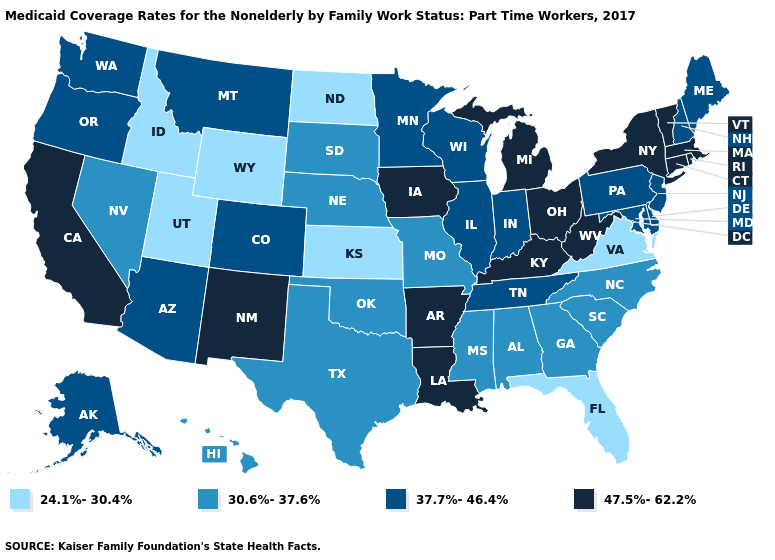How many symbols are there in the legend?
Answer briefly. 4. Name the states that have a value in the range 30.6%-37.6%?
Quick response, please. Alabama, Georgia, Hawaii, Mississippi, Missouri, Nebraska, Nevada, North Carolina, Oklahoma, South Carolina, South Dakota, Texas. Name the states that have a value in the range 30.6%-37.6%?
Concise answer only. Alabama, Georgia, Hawaii, Mississippi, Missouri, Nebraska, Nevada, North Carolina, Oklahoma, South Carolina, South Dakota, Texas. What is the value of Georgia?
Be succinct. 30.6%-37.6%. What is the value of Virginia?
Concise answer only. 24.1%-30.4%. Name the states that have a value in the range 30.6%-37.6%?
Concise answer only. Alabama, Georgia, Hawaii, Mississippi, Missouri, Nebraska, Nevada, North Carolina, Oklahoma, South Carolina, South Dakota, Texas. Does New York have the highest value in the USA?
Keep it brief. Yes. What is the lowest value in states that border Utah?
Keep it brief. 24.1%-30.4%. Does Arizona have the highest value in the USA?
Write a very short answer. No. What is the value of Hawaii?
Quick response, please. 30.6%-37.6%. Does Utah have the lowest value in the USA?
Write a very short answer. Yes. Does Louisiana have the lowest value in the USA?
Keep it brief. No. Does Louisiana have the same value as Illinois?
Concise answer only. No. Name the states that have a value in the range 30.6%-37.6%?
Answer briefly. Alabama, Georgia, Hawaii, Mississippi, Missouri, Nebraska, Nevada, North Carolina, Oklahoma, South Carolina, South Dakota, Texas. What is the highest value in the South ?
Give a very brief answer. 47.5%-62.2%. 